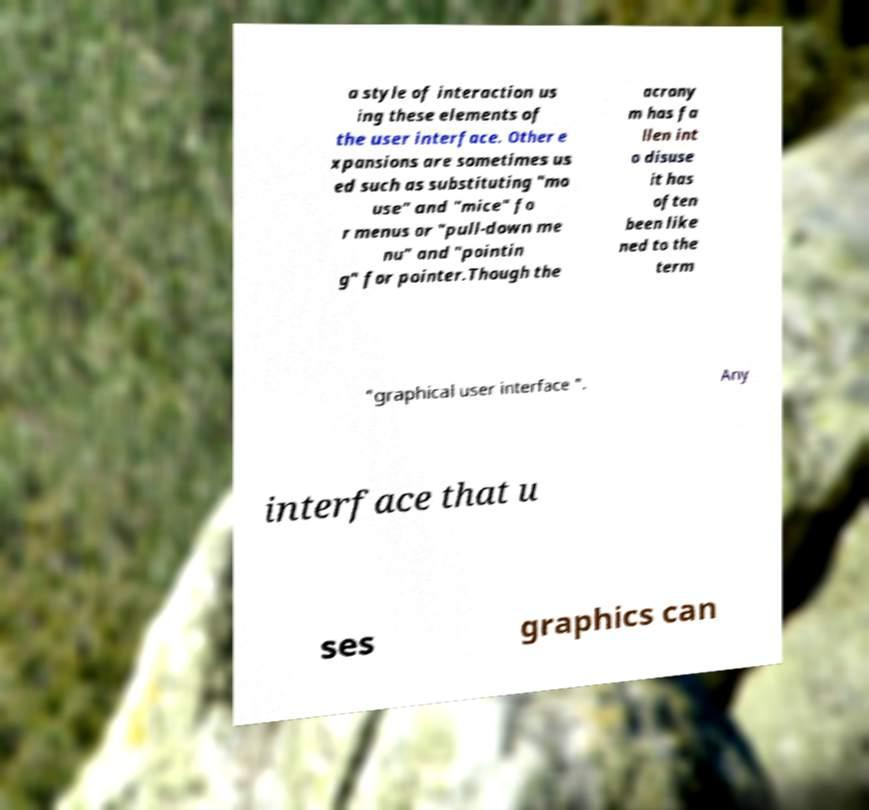Please read and relay the text visible in this image. What does it say? a style of interaction us ing these elements of the user interface. Other e xpansions are sometimes us ed such as substituting "mo use" and "mice" fo r menus or "pull-down me nu" and "pointin g" for pointer.Though the acrony m has fa llen int o disuse it has often been like ned to the term "graphical user interface ". Any interface that u ses graphics can 